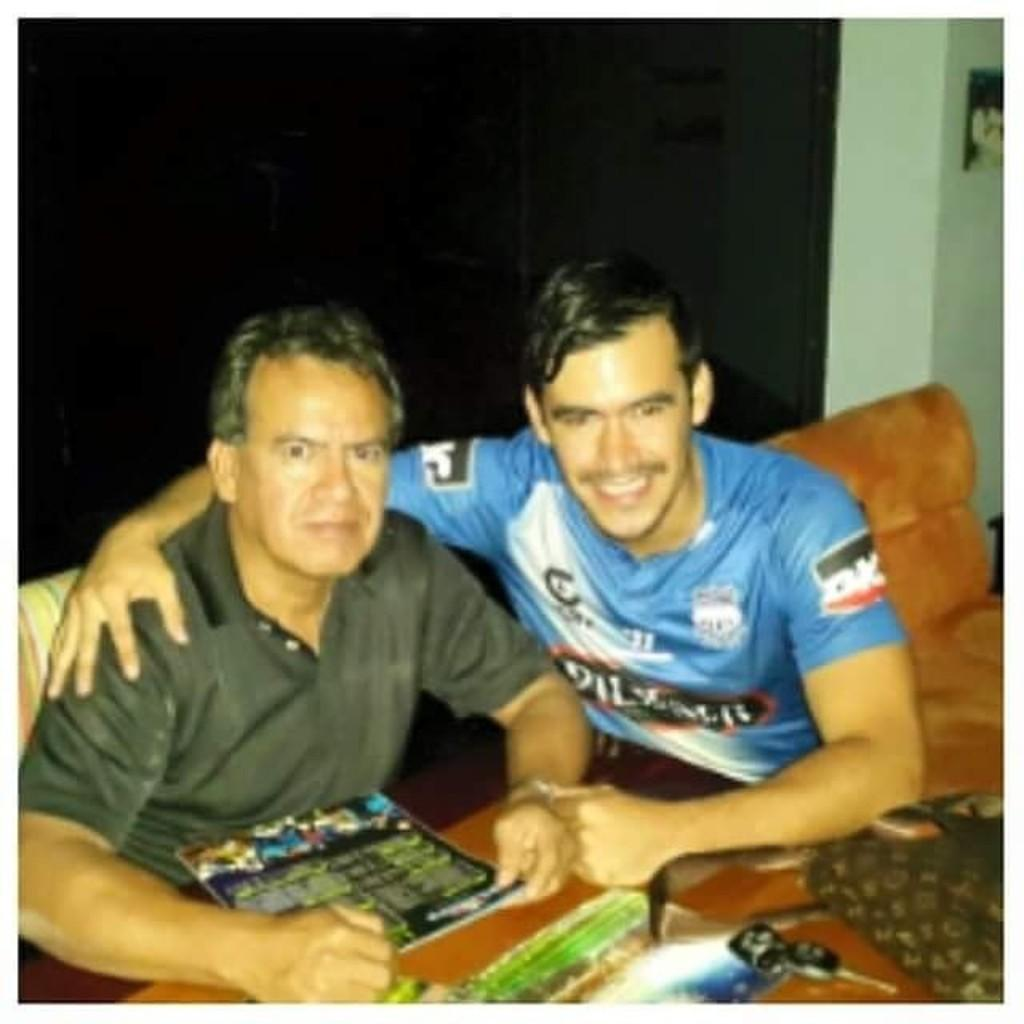How many people are in the image? There are two people in the image. What are the people doing in the image? The people are sitting on a sofa. What are the people holding in the image? The people are holding something. What can be seen behind the people in the image? There is a wall visible in the image. What type of card is the person on the left using to apply lipstick in the image? There is no card or lipstick present in the image; the people are simply holding something. 